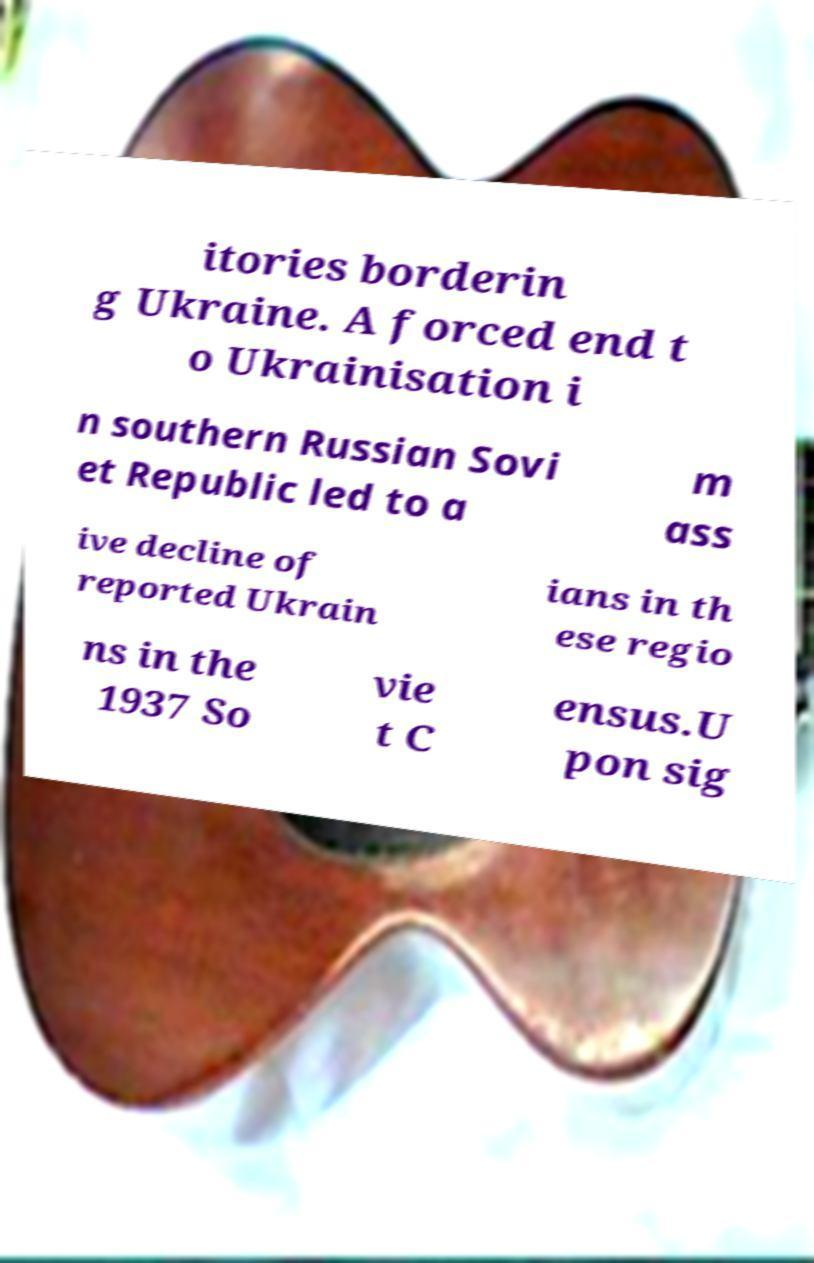What messages or text are displayed in this image? I need them in a readable, typed format. itories borderin g Ukraine. A forced end t o Ukrainisation i n southern Russian Sovi et Republic led to a m ass ive decline of reported Ukrain ians in th ese regio ns in the 1937 So vie t C ensus.U pon sig 